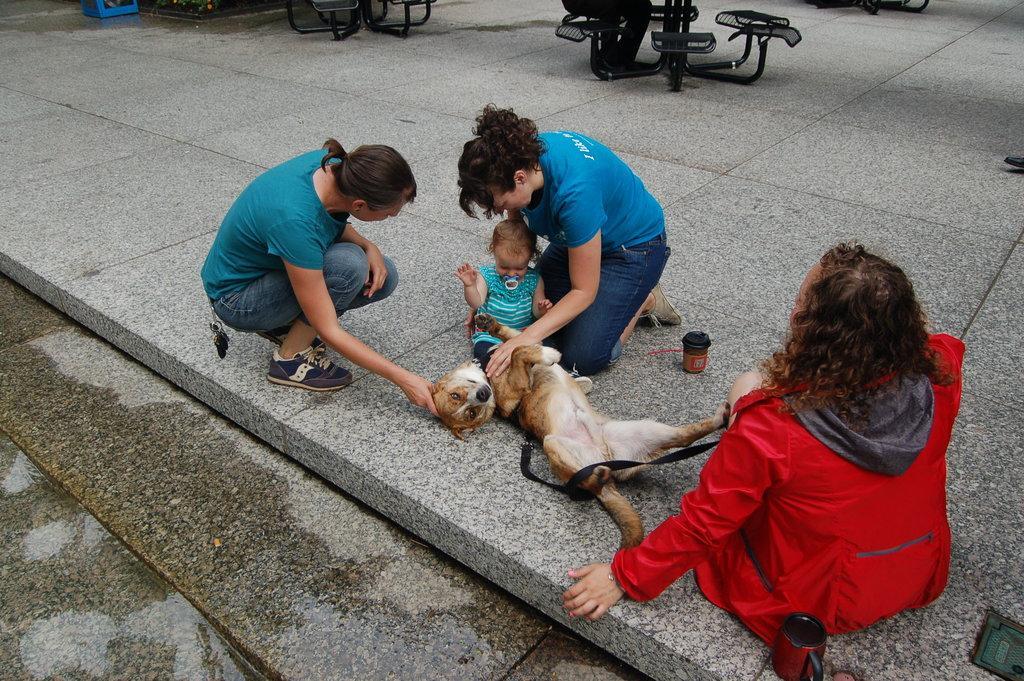Can you describe this image briefly? In this image there are group of people. The women at the right side wearing a red colour jacket is sitting on the floor. In the center there is a dog and a small girl. The women wearing a blue colour shirt in the center is keeping her hand on the dog. At the left side the person squatting is keeping the hand on the head of the dog. In the background there is a bench. At the bottom left the floor is wet. 